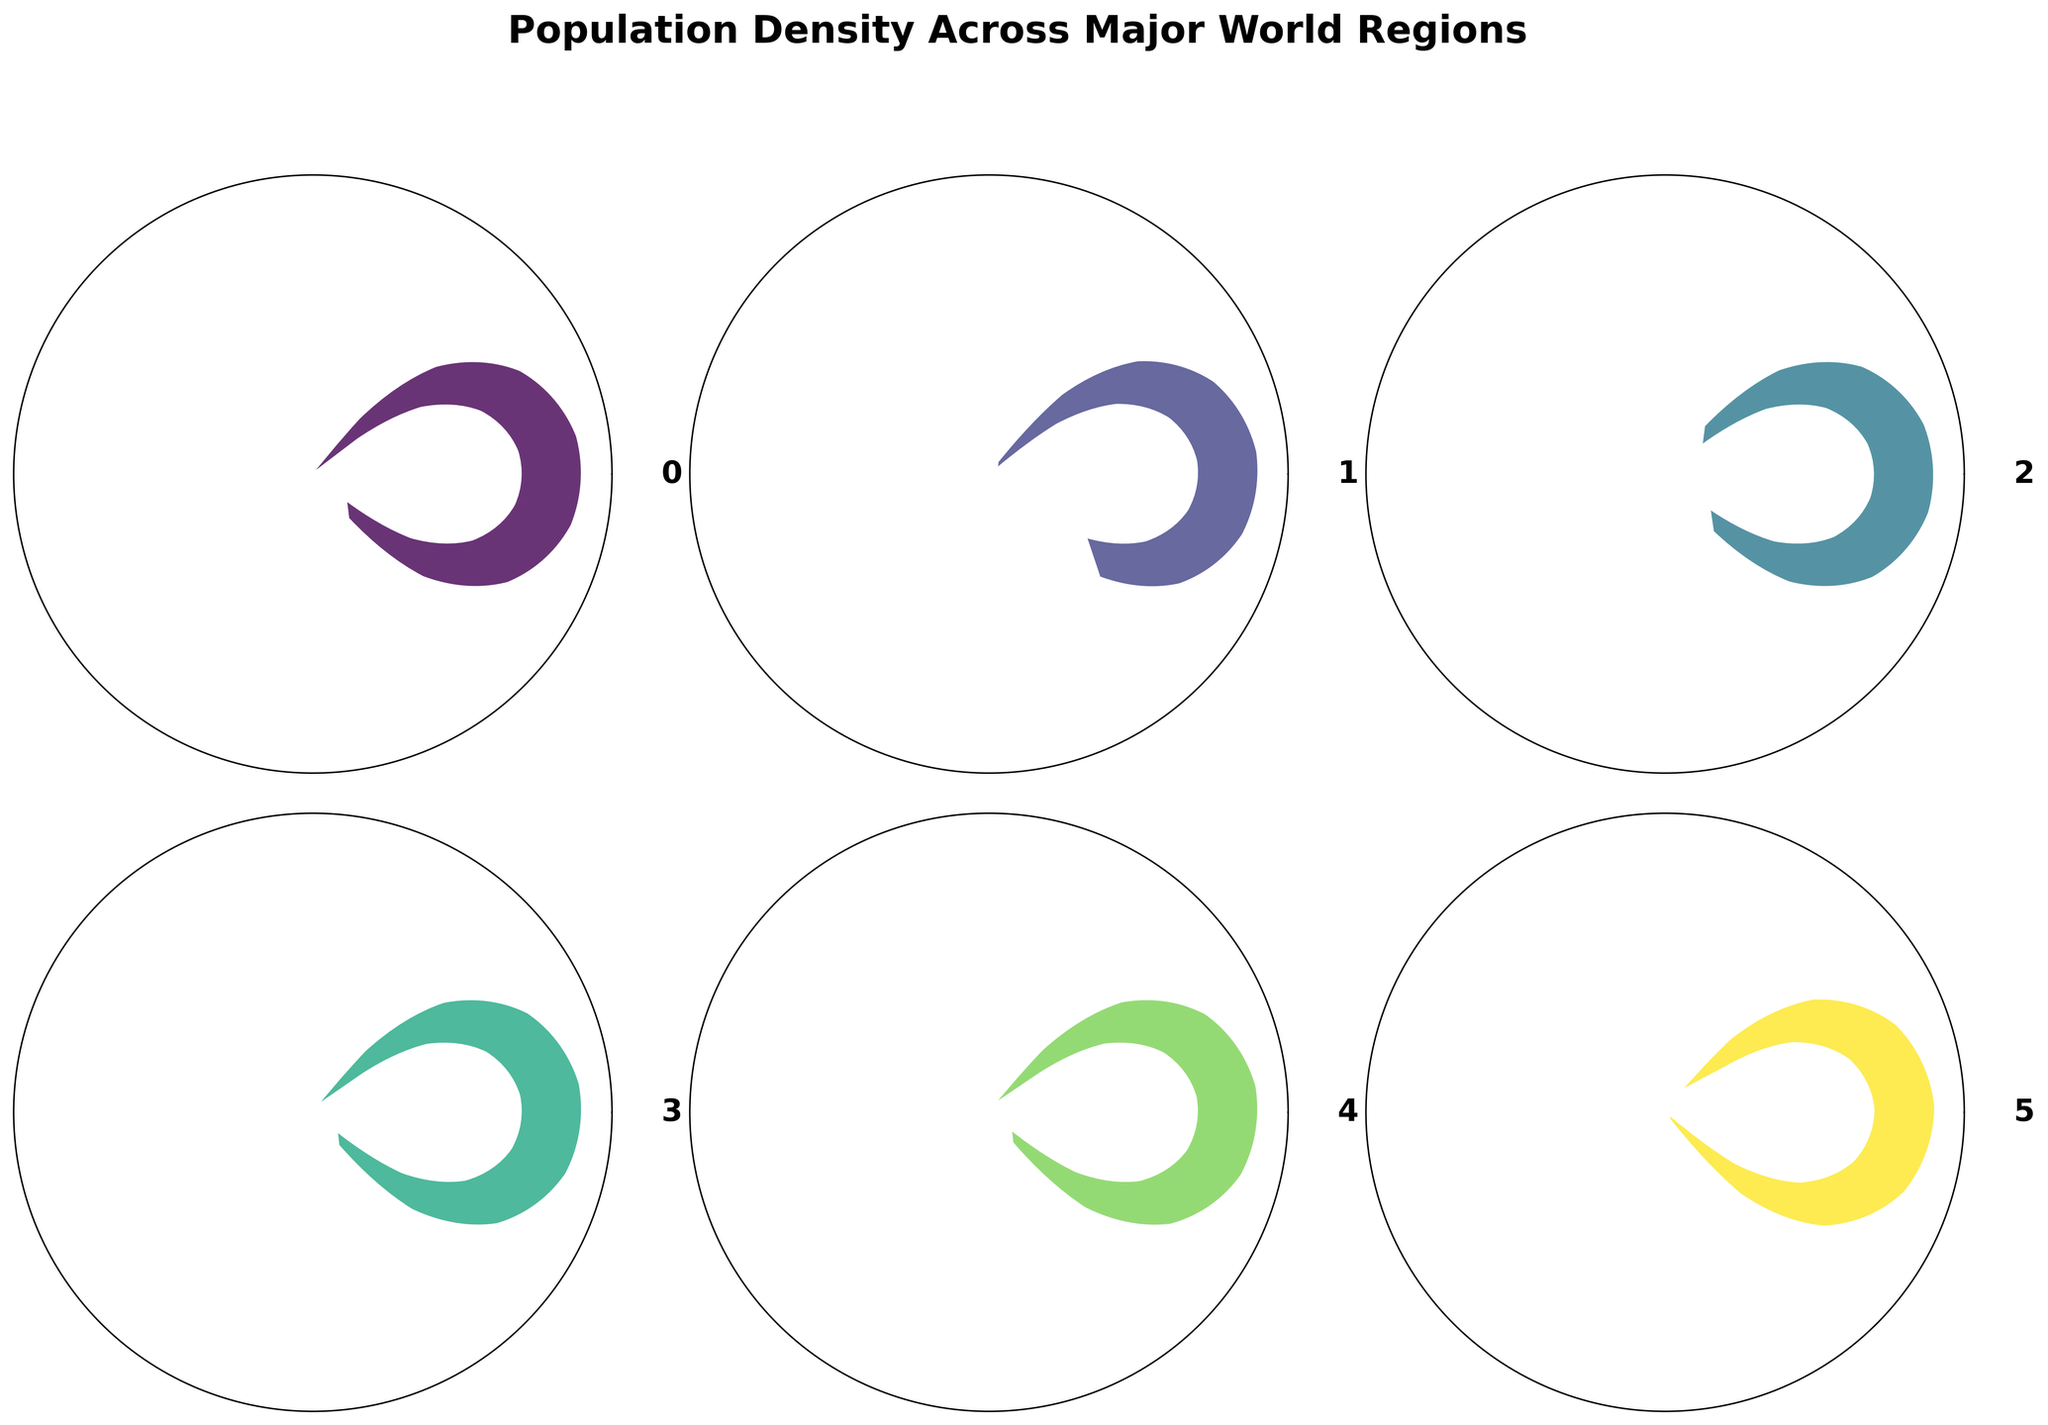What's the title of the figure? The title is placed at the top of the figure and is usually used to describe the main topic of the visualized data.
Answer: Population Density Across Major World Regions How many regions are represented in the figure? By counting the number of distinct sections (gauges), it's observed that there are six regions.
Answer: 6 Which region has the highest population density? By comparing the values shown within each gauge, Asia has the highest value at 95 people/km².
Answer: Asia Which region has the lowest population density? By comparing the values shown within each gauge, Oceania has the lowest value at 5 people/km².
Answer: Oceania What is the population density of Europe? Look at the value indicated in the gauge for Europe. It shows 34 people/km².
Answer: 34 people/km² How does the population density of North America compare to South America? Check the values in the respective gauges: North America (25 people/km²) and South America (23 people/km²). North America's population density is slightly higher than South America's.
Answer: North America's density is higher What is the average population density of all the regions combined? The average is calculated by adding all population densities and dividing by the number of regions: (34 + 95 + 45 + 25 + 23 + 5) / 6 = 227 / 6 = 37.83 people/km², approximately 38 people/km².
Answer: 38 people/km² Is the population density of Africa higher or lower than that of Europe? Compare the values: Africa has 45 people/km² and Europe has 34 people/km². Africa's population density is higher.
Answer: Higher Which region's gauge color is the darkest? The gauge colors vary in intensity based on the value, with Asia (95 people/km²) having the darkest color since it's the highest population density.
Answer: Asia What's the difference in population density between Asia and Oceania? Subtract Oceania's value from Asia's: 95 - 5 = 90 people/km².
Answer: 90 people/km² 